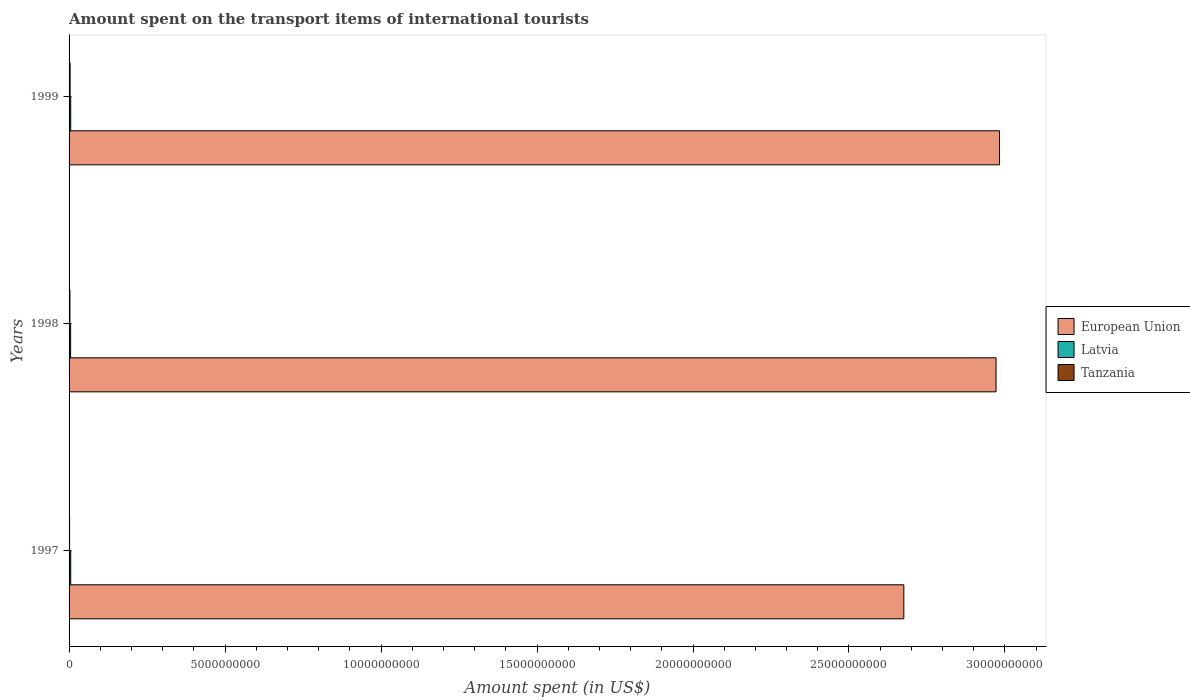How many bars are there on the 2nd tick from the bottom?
Provide a short and direct response. 3. What is the amount spent on the transport items of international tourists in Latvia in 1997?
Offer a very short reply. 5.30e+07. Across all years, what is the maximum amount spent on the transport items of international tourists in Tanzania?
Give a very brief answer. 3.30e+07. Across all years, what is the minimum amount spent on the transport items of international tourists in European Union?
Your answer should be compact. 2.68e+1. In which year was the amount spent on the transport items of international tourists in Latvia minimum?
Your answer should be compact. 1998. What is the total amount spent on the transport items of international tourists in Latvia in the graph?
Provide a succinct answer. 1.56e+08. What is the difference between the amount spent on the transport items of international tourists in Tanzania in 1997 and that in 1998?
Your answer should be compact. -1.10e+07. What is the difference between the amount spent on the transport items of international tourists in European Union in 1997 and the amount spent on the transport items of international tourists in Latvia in 1999?
Offer a terse response. 2.67e+1. What is the average amount spent on the transport items of international tourists in Latvia per year?
Provide a succinct answer. 5.20e+07. In the year 1997, what is the difference between the amount spent on the transport items of international tourists in Tanzania and amount spent on the transport items of international tourists in Latvia?
Offer a terse response. -3.60e+07. What is the ratio of the amount spent on the transport items of international tourists in Latvia in 1998 to that in 1999?
Your answer should be compact. 0.94. Is the amount spent on the transport items of international tourists in Tanzania in 1997 less than that in 1999?
Your answer should be compact. Yes. Is the difference between the amount spent on the transport items of international tourists in Tanzania in 1997 and 1999 greater than the difference between the amount spent on the transport items of international tourists in Latvia in 1997 and 1999?
Provide a succinct answer. No. What is the difference between the highest and the lowest amount spent on the transport items of international tourists in Latvia?
Your response must be concise. 3.00e+06. In how many years, is the amount spent on the transport items of international tourists in Tanzania greater than the average amount spent on the transport items of international tourists in Tanzania taken over all years?
Offer a terse response. 2. What does the 2nd bar from the bottom in 1999 represents?
Offer a very short reply. Latvia. Is it the case that in every year, the sum of the amount spent on the transport items of international tourists in Latvia and amount spent on the transport items of international tourists in Tanzania is greater than the amount spent on the transport items of international tourists in European Union?
Keep it short and to the point. No. What is the difference between two consecutive major ticks on the X-axis?
Your answer should be compact. 5.00e+09. Are the values on the major ticks of X-axis written in scientific E-notation?
Your answer should be very brief. No. Does the graph contain grids?
Provide a succinct answer. No. Where does the legend appear in the graph?
Your answer should be very brief. Center right. How many legend labels are there?
Your answer should be compact. 3. What is the title of the graph?
Your answer should be very brief. Amount spent on the transport items of international tourists. Does "Germany" appear as one of the legend labels in the graph?
Your response must be concise. No. What is the label or title of the X-axis?
Give a very brief answer. Amount spent (in US$). What is the label or title of the Y-axis?
Offer a very short reply. Years. What is the Amount spent (in US$) of European Union in 1997?
Your answer should be very brief. 2.68e+1. What is the Amount spent (in US$) in Latvia in 1997?
Offer a very short reply. 5.30e+07. What is the Amount spent (in US$) of Tanzania in 1997?
Provide a short and direct response. 1.70e+07. What is the Amount spent (in US$) of European Union in 1998?
Provide a succinct answer. 2.97e+1. What is the Amount spent (in US$) of Latvia in 1998?
Provide a short and direct response. 5.00e+07. What is the Amount spent (in US$) of Tanzania in 1998?
Provide a short and direct response. 2.80e+07. What is the Amount spent (in US$) in European Union in 1999?
Ensure brevity in your answer.  2.98e+1. What is the Amount spent (in US$) in Latvia in 1999?
Provide a short and direct response. 5.30e+07. What is the Amount spent (in US$) in Tanzania in 1999?
Ensure brevity in your answer.  3.30e+07. Across all years, what is the maximum Amount spent (in US$) in European Union?
Your response must be concise. 2.98e+1. Across all years, what is the maximum Amount spent (in US$) in Latvia?
Provide a succinct answer. 5.30e+07. Across all years, what is the maximum Amount spent (in US$) of Tanzania?
Your answer should be compact. 3.30e+07. Across all years, what is the minimum Amount spent (in US$) in European Union?
Keep it short and to the point. 2.68e+1. Across all years, what is the minimum Amount spent (in US$) in Tanzania?
Ensure brevity in your answer.  1.70e+07. What is the total Amount spent (in US$) of European Union in the graph?
Keep it short and to the point. 8.63e+1. What is the total Amount spent (in US$) of Latvia in the graph?
Give a very brief answer. 1.56e+08. What is the total Amount spent (in US$) in Tanzania in the graph?
Ensure brevity in your answer.  7.80e+07. What is the difference between the Amount spent (in US$) in European Union in 1997 and that in 1998?
Provide a succinct answer. -2.96e+09. What is the difference between the Amount spent (in US$) of Latvia in 1997 and that in 1998?
Make the answer very short. 3.00e+06. What is the difference between the Amount spent (in US$) of Tanzania in 1997 and that in 1998?
Ensure brevity in your answer.  -1.10e+07. What is the difference between the Amount spent (in US$) of European Union in 1997 and that in 1999?
Your answer should be very brief. -3.07e+09. What is the difference between the Amount spent (in US$) of Tanzania in 1997 and that in 1999?
Give a very brief answer. -1.60e+07. What is the difference between the Amount spent (in US$) of European Union in 1998 and that in 1999?
Give a very brief answer. -1.11e+08. What is the difference between the Amount spent (in US$) of Tanzania in 1998 and that in 1999?
Provide a short and direct response. -5.00e+06. What is the difference between the Amount spent (in US$) in European Union in 1997 and the Amount spent (in US$) in Latvia in 1998?
Your response must be concise. 2.67e+1. What is the difference between the Amount spent (in US$) of European Union in 1997 and the Amount spent (in US$) of Tanzania in 1998?
Your response must be concise. 2.67e+1. What is the difference between the Amount spent (in US$) of Latvia in 1997 and the Amount spent (in US$) of Tanzania in 1998?
Keep it short and to the point. 2.50e+07. What is the difference between the Amount spent (in US$) in European Union in 1997 and the Amount spent (in US$) in Latvia in 1999?
Your response must be concise. 2.67e+1. What is the difference between the Amount spent (in US$) in European Union in 1997 and the Amount spent (in US$) in Tanzania in 1999?
Offer a very short reply. 2.67e+1. What is the difference between the Amount spent (in US$) of European Union in 1998 and the Amount spent (in US$) of Latvia in 1999?
Your answer should be compact. 2.97e+1. What is the difference between the Amount spent (in US$) of European Union in 1998 and the Amount spent (in US$) of Tanzania in 1999?
Your answer should be compact. 2.97e+1. What is the difference between the Amount spent (in US$) of Latvia in 1998 and the Amount spent (in US$) of Tanzania in 1999?
Offer a terse response. 1.70e+07. What is the average Amount spent (in US$) in European Union per year?
Offer a very short reply. 2.88e+1. What is the average Amount spent (in US$) of Latvia per year?
Keep it short and to the point. 5.20e+07. What is the average Amount spent (in US$) in Tanzania per year?
Make the answer very short. 2.60e+07. In the year 1997, what is the difference between the Amount spent (in US$) of European Union and Amount spent (in US$) of Latvia?
Make the answer very short. 2.67e+1. In the year 1997, what is the difference between the Amount spent (in US$) of European Union and Amount spent (in US$) of Tanzania?
Your answer should be very brief. 2.67e+1. In the year 1997, what is the difference between the Amount spent (in US$) of Latvia and Amount spent (in US$) of Tanzania?
Offer a terse response. 3.60e+07. In the year 1998, what is the difference between the Amount spent (in US$) of European Union and Amount spent (in US$) of Latvia?
Offer a terse response. 2.97e+1. In the year 1998, what is the difference between the Amount spent (in US$) of European Union and Amount spent (in US$) of Tanzania?
Offer a very short reply. 2.97e+1. In the year 1998, what is the difference between the Amount spent (in US$) of Latvia and Amount spent (in US$) of Tanzania?
Offer a terse response. 2.20e+07. In the year 1999, what is the difference between the Amount spent (in US$) of European Union and Amount spent (in US$) of Latvia?
Provide a short and direct response. 2.98e+1. In the year 1999, what is the difference between the Amount spent (in US$) of European Union and Amount spent (in US$) of Tanzania?
Provide a succinct answer. 2.98e+1. In the year 1999, what is the difference between the Amount spent (in US$) in Latvia and Amount spent (in US$) in Tanzania?
Provide a short and direct response. 2.00e+07. What is the ratio of the Amount spent (in US$) in European Union in 1997 to that in 1998?
Offer a very short reply. 0.9. What is the ratio of the Amount spent (in US$) in Latvia in 1997 to that in 1998?
Offer a terse response. 1.06. What is the ratio of the Amount spent (in US$) in Tanzania in 1997 to that in 1998?
Provide a short and direct response. 0.61. What is the ratio of the Amount spent (in US$) in European Union in 1997 to that in 1999?
Keep it short and to the point. 0.9. What is the ratio of the Amount spent (in US$) in Latvia in 1997 to that in 1999?
Provide a short and direct response. 1. What is the ratio of the Amount spent (in US$) in Tanzania in 1997 to that in 1999?
Offer a very short reply. 0.52. What is the ratio of the Amount spent (in US$) of Latvia in 1998 to that in 1999?
Ensure brevity in your answer.  0.94. What is the ratio of the Amount spent (in US$) in Tanzania in 1998 to that in 1999?
Your answer should be compact. 0.85. What is the difference between the highest and the second highest Amount spent (in US$) in European Union?
Keep it short and to the point. 1.11e+08. What is the difference between the highest and the second highest Amount spent (in US$) in Latvia?
Make the answer very short. 0. What is the difference between the highest and the lowest Amount spent (in US$) in European Union?
Offer a terse response. 3.07e+09. What is the difference between the highest and the lowest Amount spent (in US$) of Tanzania?
Give a very brief answer. 1.60e+07. 